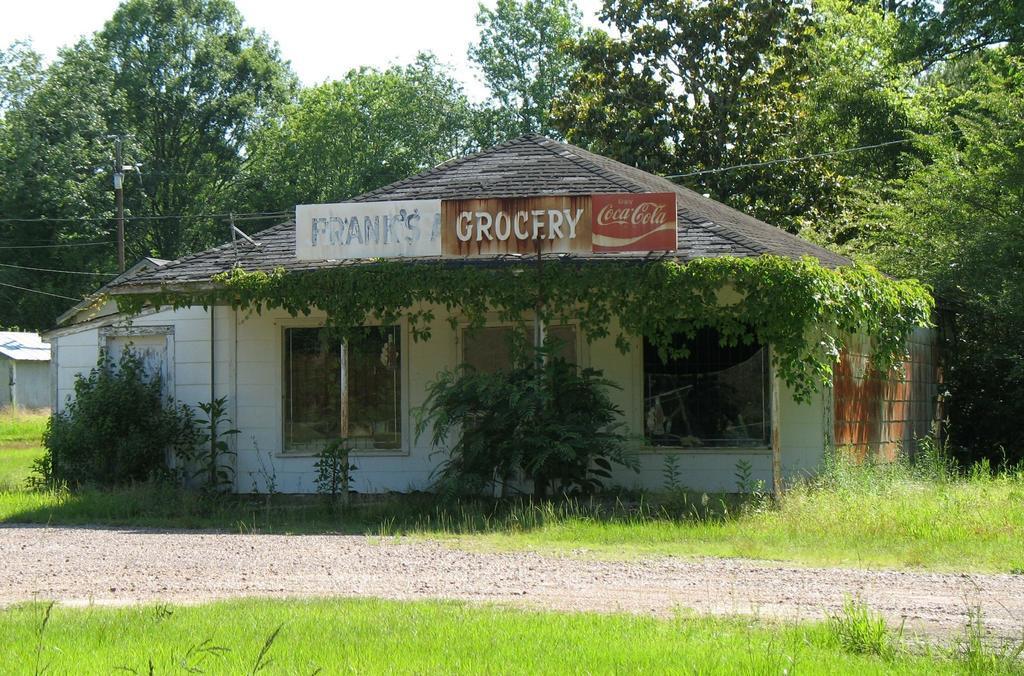Describe this image in one or two sentences. In this image we can see house which is in the shape of hut and there is a board attached to it there are some plants around it and in the background of the image there are some trees and clear sky. 